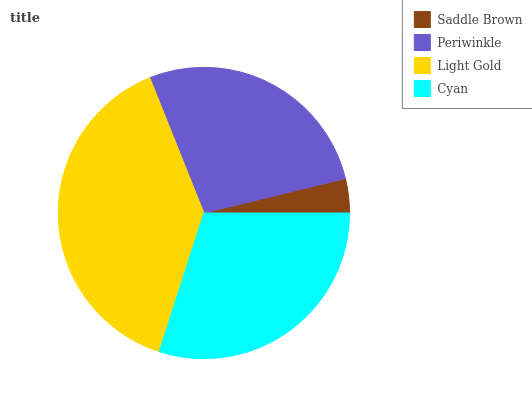Is Saddle Brown the minimum?
Answer yes or no. Yes. Is Light Gold the maximum?
Answer yes or no. Yes. Is Periwinkle the minimum?
Answer yes or no. No. Is Periwinkle the maximum?
Answer yes or no. No. Is Periwinkle greater than Saddle Brown?
Answer yes or no. Yes. Is Saddle Brown less than Periwinkle?
Answer yes or no. Yes. Is Saddle Brown greater than Periwinkle?
Answer yes or no. No. Is Periwinkle less than Saddle Brown?
Answer yes or no. No. Is Cyan the high median?
Answer yes or no. Yes. Is Periwinkle the low median?
Answer yes or no. Yes. Is Saddle Brown the high median?
Answer yes or no. No. Is Saddle Brown the low median?
Answer yes or no. No. 